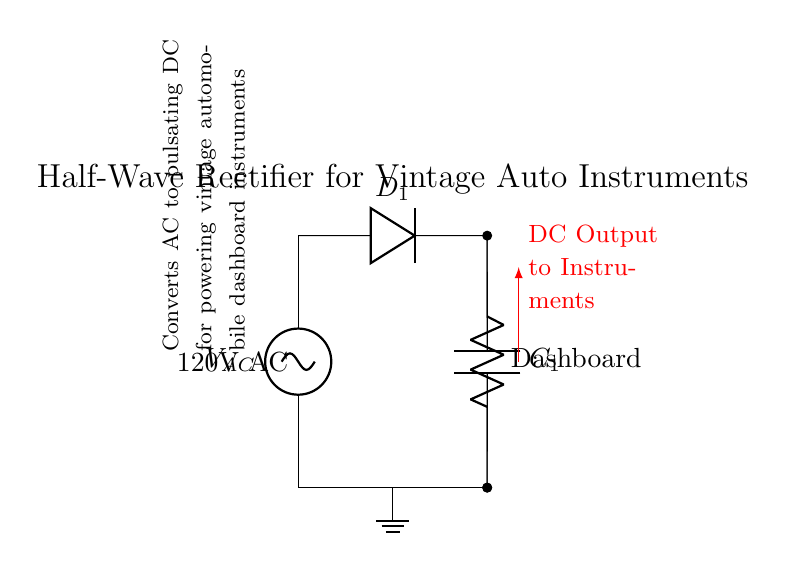What type of diode is used in this circuit? The circuit diagram identifies the diode as represented by the symbol for a diode, which indicates its type suited for rectification in this specific layout.
Answer: Diode What is the load connected to the rectifier? The circuit shows a resistor labeled "Dashboard" connected to the output of the rectifier, indicating that it is the load being powered by the rectified output.
Answer: Dashboard What is the input voltage of this circuit? The circuit clearly labels the input voltage as "120V AC," which refers to the alternating current source that provides power to the rectifier circuit.
Answer: 120V AC What component smooths the pulsating DC output? The capacitor, labeled as "C1," is indicated in the circuit diagram to be connected in parallel with the load resistor. Its primary function is to smooth out the fluctuations in the pulsating DC voltage.
Answer: C1 How many diodes are used in this half-wave rectifier? The diagram shows only one diode connected in the circuit, which is characteristic of half-wave rectifier circuits that only utilize a single diode to allow current to flow during one half of the AC cycle.
Answer: One What is the purpose of this half-wave rectifier? The diagram includes a note stating that the rectifier converts AC to pulsating DC specifically for powering vintage automobile dashboard instruments. This outlines the purpose of the circuit in context.
Answer: Convert AC to DC What type of connection is used for the ground? The circuit illustrates a ground connection symbol, which indicates that the common reference point for the circuit is grounded, allowing for a return path for the current.
Answer: Ground 